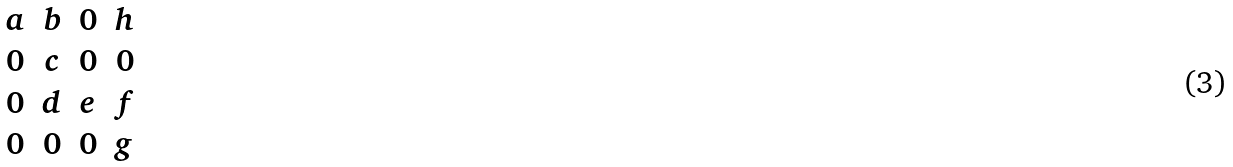Convert formula to latex. <formula><loc_0><loc_0><loc_500><loc_500>\begin{matrix} a & b & 0 & h \\ 0 & c & 0 & 0 \\ 0 & d & e & f \\ 0 & 0 & 0 & g \end{matrix}</formula> 